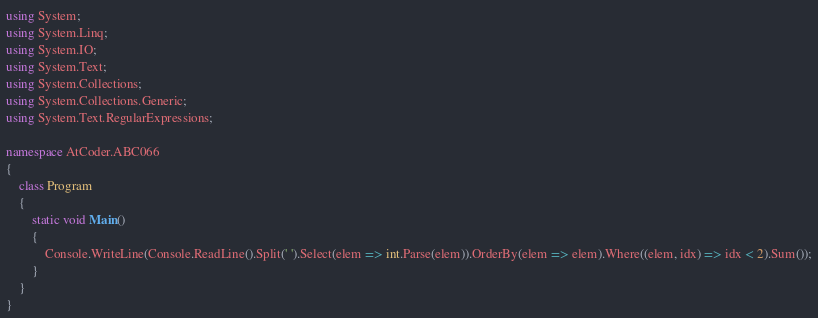<code> <loc_0><loc_0><loc_500><loc_500><_C#_>using System;
using System.Linq;
using System.IO;
using System.Text;
using System.Collections;
using System.Collections.Generic;
using System.Text.RegularExpressions;

namespace AtCoder.ABC066
{
    class Program
    {
        static void Main()
        {
            Console.WriteLine(Console.ReadLine().Split(' ').Select(elem => int.Parse(elem)).OrderBy(elem => elem).Where((elem, idx) => idx < 2).Sum());
        }
    }
}</code> 